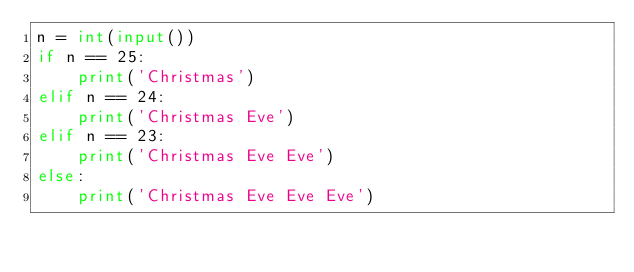Convert code to text. <code><loc_0><loc_0><loc_500><loc_500><_Python_>n = int(input())
if n == 25:
    print('Christmas')
elif n == 24:
    print('Christmas Eve')
elif n == 23:
    print('Christmas Eve Eve')
else:
    print('Christmas Eve Eve Eve')</code> 